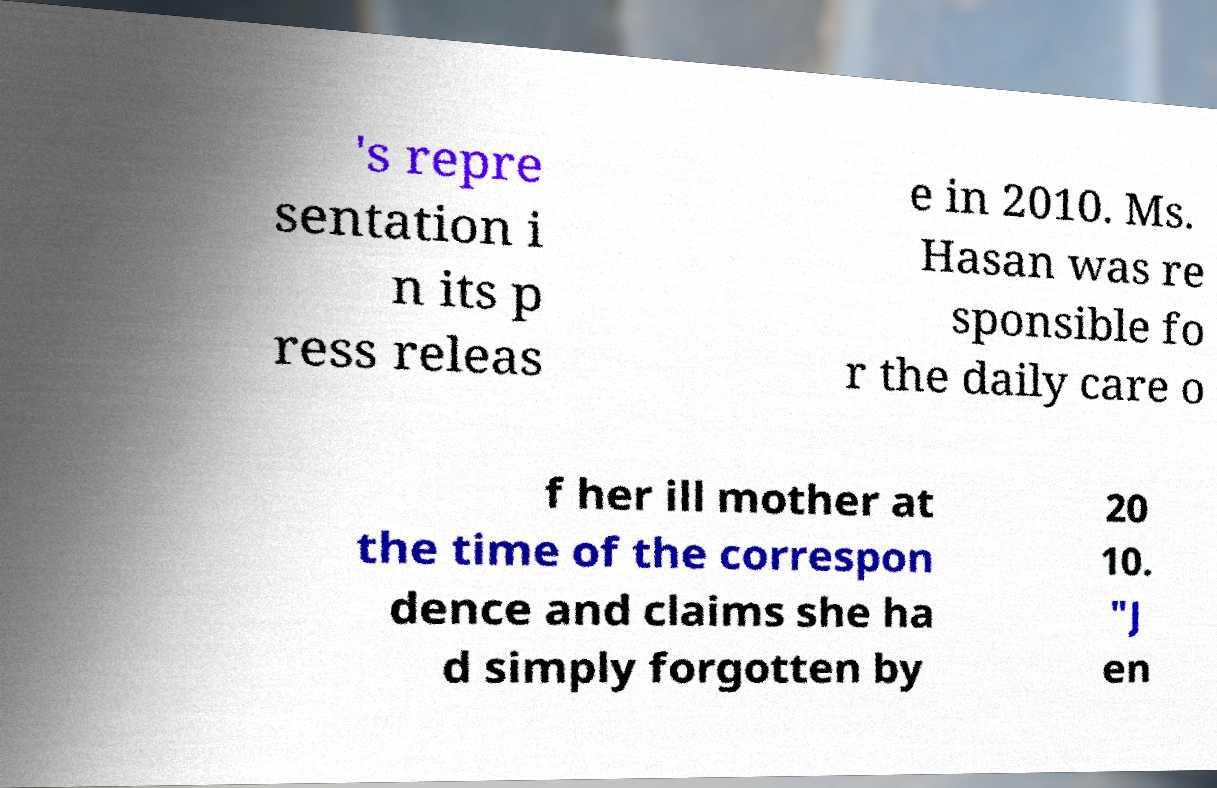There's text embedded in this image that I need extracted. Can you transcribe it verbatim? 's repre sentation i n its p ress releas e in 2010. Ms. Hasan was re sponsible fo r the daily care o f her ill mother at the time of the correspon dence and claims she ha d simply forgotten by 20 10. "J en 